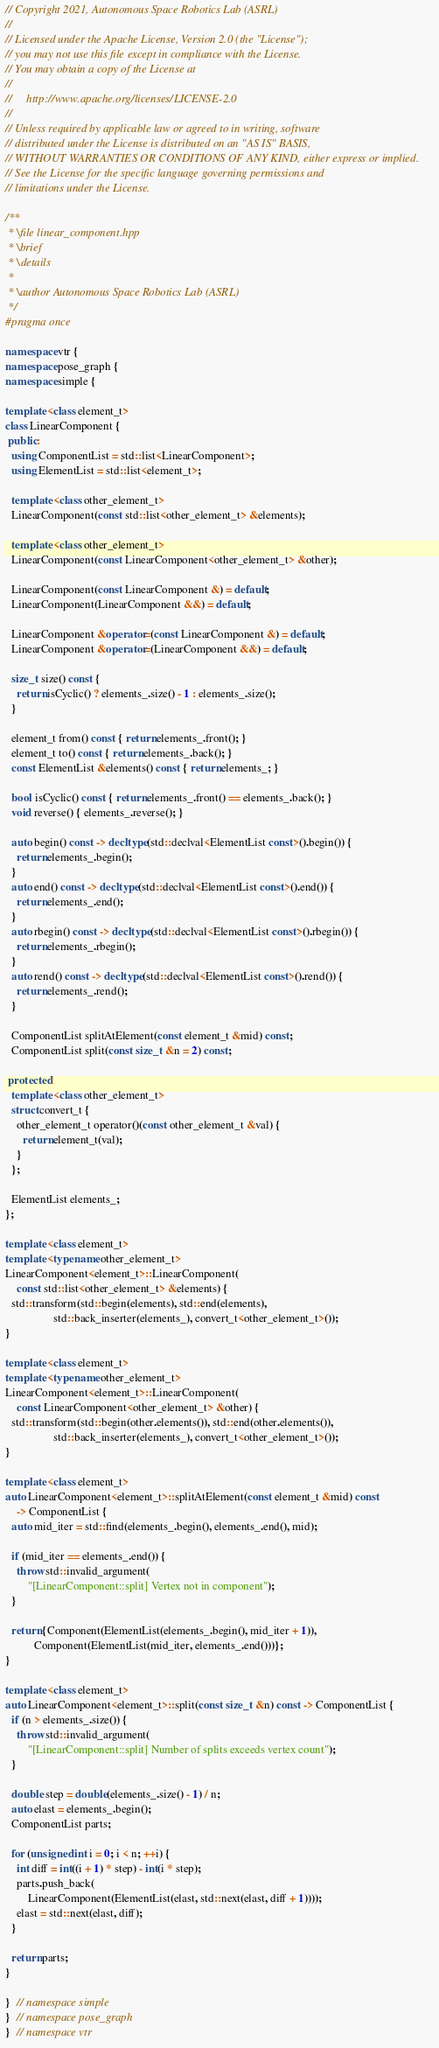<code> <loc_0><loc_0><loc_500><loc_500><_C++_>// Copyright 2021, Autonomous Space Robotics Lab (ASRL)
//
// Licensed under the Apache License, Version 2.0 (the "License");
// you may not use this file except in compliance with the License.
// You may obtain a copy of the License at
//
//     http://www.apache.org/licenses/LICENSE-2.0
//
// Unless required by applicable law or agreed to in writing, software
// distributed under the License is distributed on an "AS IS" BASIS,
// WITHOUT WARRANTIES OR CONDITIONS OF ANY KIND, either express or implied.
// See the License for the specific language governing permissions and
// limitations under the License.

/**
 * \file linear_component.hpp
 * \brief
 * \details
 *
 * \author Autonomous Space Robotics Lab (ASRL)
 */
#pragma once

namespace vtr {
namespace pose_graph {
namespace simple {

template <class element_t>
class LinearComponent {
 public:
  using ComponentList = std::list<LinearComponent>;
  using ElementList = std::list<element_t>;

  template <class other_element_t>
  LinearComponent(const std::list<other_element_t> &elements);

  template <class other_element_t>
  LinearComponent(const LinearComponent<other_element_t> &other);

  LinearComponent(const LinearComponent &) = default;
  LinearComponent(LinearComponent &&) = default;

  LinearComponent &operator=(const LinearComponent &) = default;
  LinearComponent &operator=(LinearComponent &&) = default;

  size_t size() const {
    return isCyclic() ? elements_.size() - 1 : elements_.size();
  }

  element_t from() const { return elements_.front(); }
  element_t to() const { return elements_.back(); }
  const ElementList &elements() const { return elements_; }

  bool isCyclic() const { return elements_.front() == elements_.back(); }
  void reverse() { elements_.reverse(); }

  auto begin() const -> decltype(std::declval<ElementList const>().begin()) {
    return elements_.begin();
  }
  auto end() const -> decltype(std::declval<ElementList const>().end()) {
    return elements_.end();
  }
  auto rbegin() const -> decltype(std::declval<ElementList const>().rbegin()) {
    return elements_.rbegin();
  }
  auto rend() const -> decltype(std::declval<ElementList const>().rend()) {
    return elements_.rend();
  }

  ComponentList splitAtElement(const element_t &mid) const;
  ComponentList split(const size_t &n = 2) const;

 protected:
  template <class other_element_t>
  struct convert_t {
    other_element_t operator()(const other_element_t &val) {
      return element_t(val);
    }
  };

  ElementList elements_;
};

template <class element_t>
template <typename other_element_t>
LinearComponent<element_t>::LinearComponent(
    const std::list<other_element_t> &elements) {
  std::transform(std::begin(elements), std::end(elements),
                 std::back_inserter(elements_), convert_t<other_element_t>());
}

template <class element_t>
template <typename other_element_t>
LinearComponent<element_t>::LinearComponent(
    const LinearComponent<other_element_t> &other) {
  std::transform(std::begin(other.elements()), std::end(other.elements()),
                 std::back_inserter(elements_), convert_t<other_element_t>());
}

template <class element_t>
auto LinearComponent<element_t>::splitAtElement(const element_t &mid) const
    -> ComponentList {
  auto mid_iter = std::find(elements_.begin(), elements_.end(), mid);

  if (mid_iter == elements_.end()) {
    throw std::invalid_argument(
        "[LinearComponent::split] Vertex not in component");
  }

  return {Component(ElementList(elements_.begin(), mid_iter + 1)),
          Component(ElementList(mid_iter, elements_.end()))};
}

template <class element_t>
auto LinearComponent<element_t>::split(const size_t &n) const -> ComponentList {
  if (n > elements_.size()) {
    throw std::invalid_argument(
        "[LinearComponent::split] Number of splits exceeds vertex count");
  }

  double step = double(elements_.size() - 1) / n;
  auto elast = elements_.begin();
  ComponentList parts;

  for (unsigned int i = 0; i < n; ++i) {
    int diff = int((i + 1) * step) - int(i * step);
    parts.push_back(
        LinearComponent(ElementList(elast, std::next(elast, diff + 1))));
    elast = std::next(elast, diff);
  }

  return parts;
}

}  // namespace simple
}  // namespace pose_graph
}  // namespace vtr
</code> 